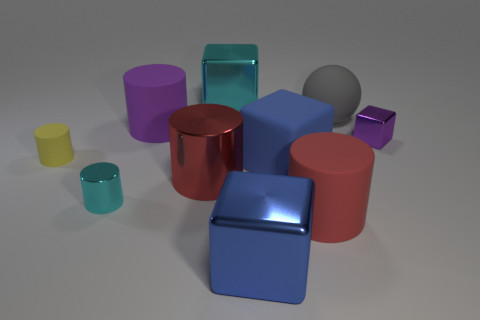There is a cyan shiny object that is behind the big metallic thing that is on the left side of the large cyan metal cube; what number of small metal things are behind it?
Your response must be concise. 0. How many objects are in front of the large purple cylinder and on the right side of the small cyan metallic thing?
Provide a succinct answer. 5. Are there more blocks that are in front of the big rubber ball than tiny yellow objects?
Give a very brief answer. Yes. What number of other objects are the same size as the yellow matte thing?
Provide a succinct answer. 2. There is a rubber object that is the same color as the tiny metallic block; what is its size?
Your answer should be compact. Large. What number of small objects are gray objects or blue shiny blocks?
Provide a succinct answer. 0. How many large gray matte cylinders are there?
Your answer should be very brief. 0. Is the number of small purple metal cubes in front of the large blue metallic cube the same as the number of large rubber balls that are behind the tiny cyan metallic cylinder?
Ensure brevity in your answer.  No. There is a large cyan block; are there any cylinders to the left of it?
Your answer should be very brief. Yes. What color is the large metallic cube behind the large purple rubber object?
Provide a succinct answer. Cyan. 